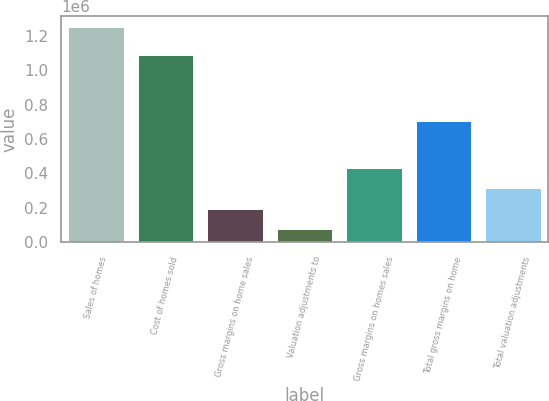<chart> <loc_0><loc_0><loc_500><loc_500><bar_chart><fcel>Sales of homes<fcel>Cost of homes sold<fcel>Gross margins on home sales<fcel>Valuation adjustments to<fcel>Gross margins on homes sales<fcel>Total gross margins on home<fcel>Total valuation adjustments<nl><fcel>1.25272e+06<fcel>1.08823e+06<fcel>194384<fcel>76791<fcel>429571<fcel>705145<fcel>311978<nl></chart> 